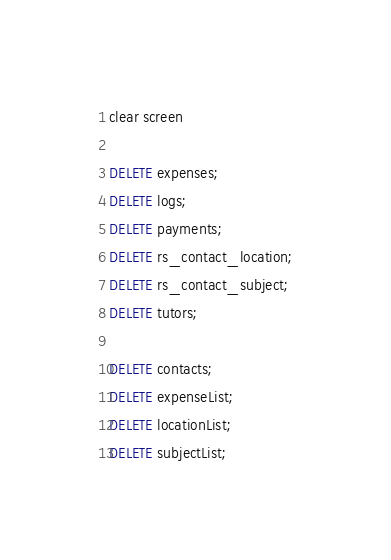Convert code to text. <code><loc_0><loc_0><loc_500><loc_500><_SQL_>clear screen

DELETE expenses;
DELETE logs;
DELETE payments;
DELETE rs_contact_location;
DELETE rs_contact_subject;
DELETE tutors;

DELETE contacts;
DELETE expenseList;
DELETE locationList;
DELETE subjectList;
</code> 